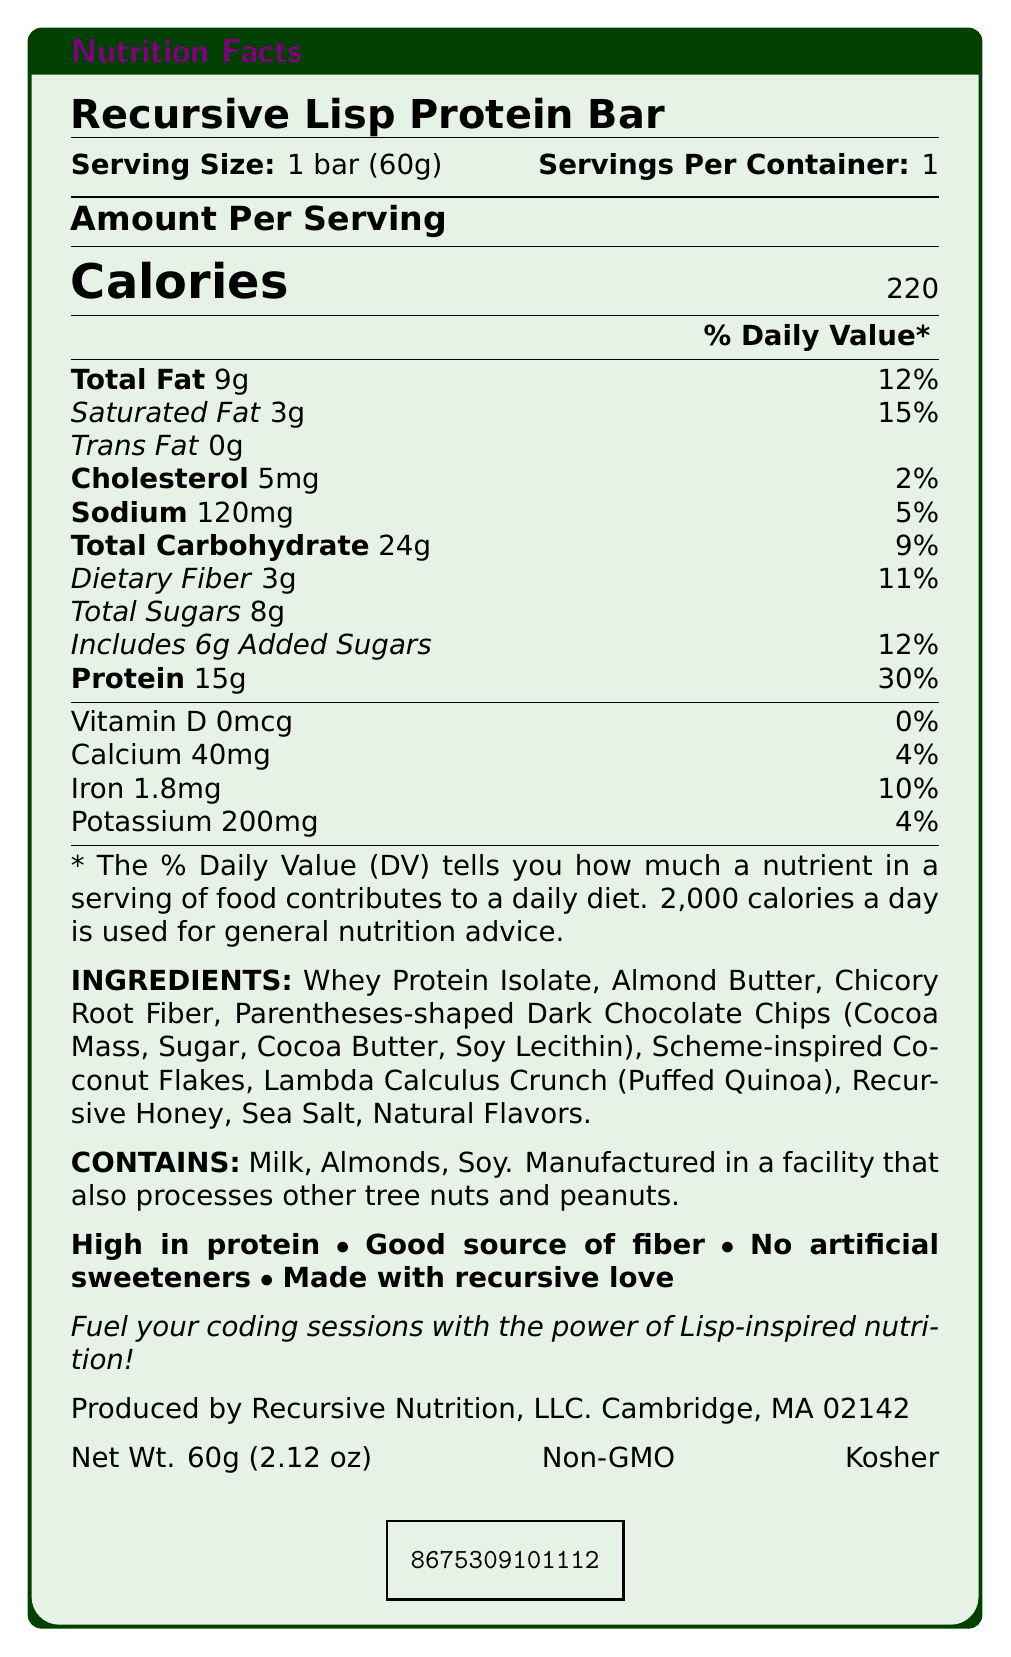What is the serving size of the Recursive Lisp Protein Bar? The serving size is mentioned at the top of the document as "Serving Size: 1 bar (60g)".
Answer: 1 bar (60g) How many calories are there per serving of the protein bar? The calories per serving are clearly indicated as 220 under the "Amount Per Serving" section.
Answer: 220 What is the total fat content per serving? The total fat content per serving is specified under "Total Fat: 9g".
Answer: 9g List the vitamins and minerals present in the protein bar along with their daily value percentages. The vitamins and minerals with their amounts and daily values are listed at the bottom of the nutrient section: Vitamin D 0mcg 0%, Calcium 40mg 4%, Iron 1.8mg 10%, Potassium 200mg 4%.
Answer: Vitamin D 0mcg 0%, Calcium 40mg 4%, Iron 1.8mg 10%, Potassium 200mg 4% Is this protein bar high in protein? The claim statement at the bottom of the document explicitly mentions "High in protein".
Answer: Yes .contains
Which allergens does the protein bar contain? A. Milk, Almonds, Soy B. Peanuts, Almonds, Milk C. Soy, Tree Nuts, Almonds D. Milk, Peanuts, Soy The allergen information states "Contains: Milk, Almonds, Soy".
Answer: A What is the primary ingredient of the Recursive Lisp Protein Bar? The ingredients are listed in descending order of quantity, and the first ingredient is "Whey Protein Isolate".
Answer: Whey Protein Isolate What is the sodium content per serving, and what percentage of the daily value does it cover? The sodium content is mentioned as "Sodium: 120mg" with a daily value of 5%.
Answer: 120mg, 5% How much protein is there per serving, and what percentage of the daily value does it represent? The document lists the protein content as "Protein 15g" with a daily value of 30%.
Answer: 15g, 30% What are the unique or standout ingredients in the protein bar related to Lisp or Scheme? These unique ingredients are listed under "Ingredients": Parentheses-shaped Dark Chocolate Chips, Scheme-inspired Coconut Flakes, Lambda Calculus Crunch (Puffed Quinoa), Recursive Honey.
Answer: Parentheses-shaped Dark Chocolate Chips, Scheme-inspired Coconut Flakes, Lambda Calculus Crunch (Puffed Quinoa), Recursive Honey Which of the following is NOT an ingredient in the Recursive Lisp Protein Bar? I. Chicory Root Fiber II. Whey Protein Isolate III. Artificial Sweeteners IV. Almond Butter The list of ingredients does not mention "Artificial Sweeteners," and the claim statement states "No artificial sweeteners."
Answer: III. Artificial Sweeteners Is the Recursive Lisp Protein Bar USDA Organic certified? The document mentions that the product is "Non-GMO" and "Kosher," but it explicitly indicates that it is not USDA Organic.
Answer: No Summarize the purpose and key features of the Recursive Lisp Protein Bar as described in the document. The document highlights the nutritional content, unique Lisp-themed ingredients, allergen information, claims such as "high in protein" and "no artificial sweeteners," and additional features like being non-GMO and kosher.
Answer: The Recursive Lisp Protein Bar is designed to fuel coding sessions with Lisp-inspired nutrition. It features 220 calories per serving, is high in protein (15g per serving, 30% DV), and contains no artificial sweeteners. It includes unique ingredients like parentheses-shaped dark chocolate chips and lambda calculus crunch. The bar contains milk, almonds, and soy and is non-GMO and kosher. Who can I contact to purchase the Recursive Lisp Protein Bar in bulk? The document does not provide specific contact details for bulk purchases. The manufacturer information is given as "Recursive Nutrition, LLC. Cambridge, MA 02142" but no contact details.
Answer: Not enough information 